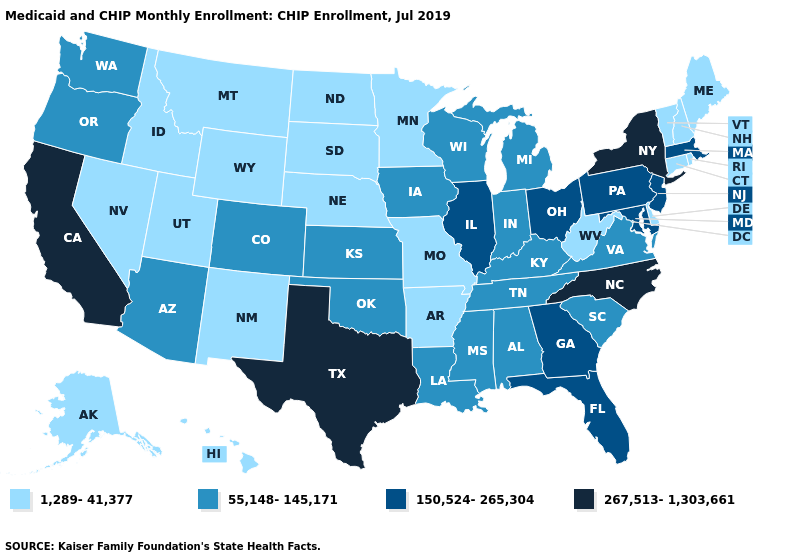What is the value of Minnesota?
Write a very short answer. 1,289-41,377. Among the states that border Florida , which have the highest value?
Quick response, please. Georgia. Which states have the highest value in the USA?
Give a very brief answer. California, New York, North Carolina, Texas. Does Florida have the lowest value in the USA?
Answer briefly. No. Does Oklahoma have the highest value in the South?
Give a very brief answer. No. What is the highest value in states that border Rhode Island?
Be succinct. 150,524-265,304. What is the lowest value in the USA?
Answer briefly. 1,289-41,377. What is the value of Iowa?
Give a very brief answer. 55,148-145,171. Name the states that have a value in the range 267,513-1,303,661?
Short answer required. California, New York, North Carolina, Texas. Does Arkansas have the lowest value in the South?
Quick response, please. Yes. Name the states that have a value in the range 150,524-265,304?
Quick response, please. Florida, Georgia, Illinois, Maryland, Massachusetts, New Jersey, Ohio, Pennsylvania. Name the states that have a value in the range 267,513-1,303,661?
Be succinct. California, New York, North Carolina, Texas. Which states have the lowest value in the USA?
Write a very short answer. Alaska, Arkansas, Connecticut, Delaware, Hawaii, Idaho, Maine, Minnesota, Missouri, Montana, Nebraska, Nevada, New Hampshire, New Mexico, North Dakota, Rhode Island, South Dakota, Utah, Vermont, West Virginia, Wyoming. What is the highest value in the USA?
Give a very brief answer. 267,513-1,303,661. 